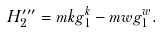Convert formula to latex. <formula><loc_0><loc_0><loc_500><loc_500>H ^ { \prime \prime \prime } _ { 2 } = m k g _ { 1 } ^ { k } - m w g _ { 1 } ^ { w } .</formula> 